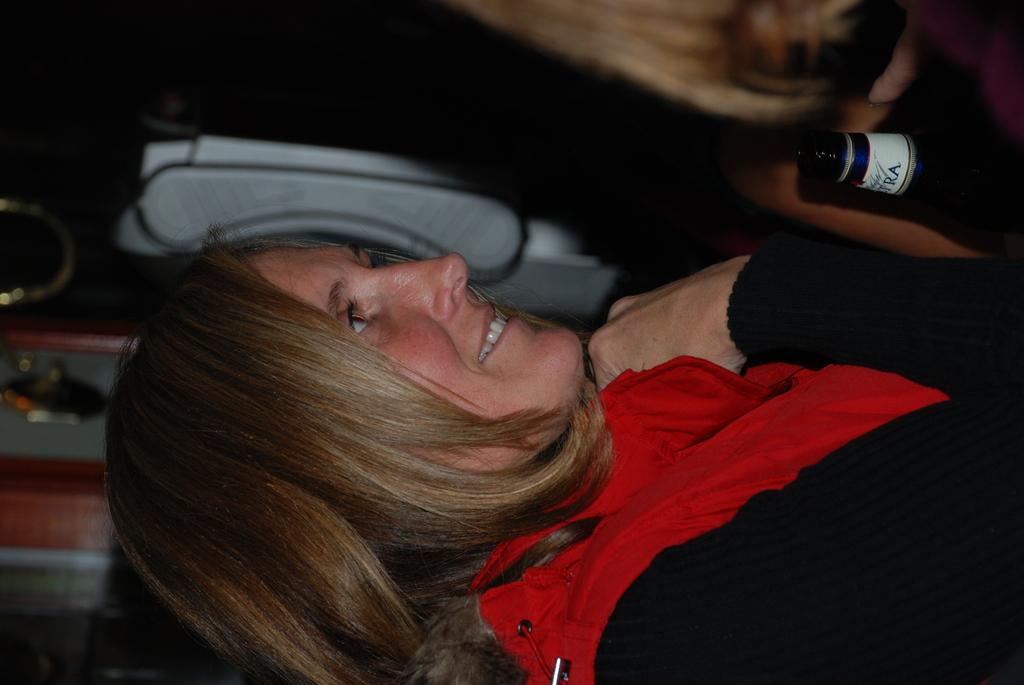What is the main subject of the image? The main subject of the image is a woman. What object is in front of the woman? There is a bottle in front of the woman. What type of scale is the woman using to weigh the bottle in the image? There is no scale present in the image, and the woman is not using any scale to weigh the bottle. 